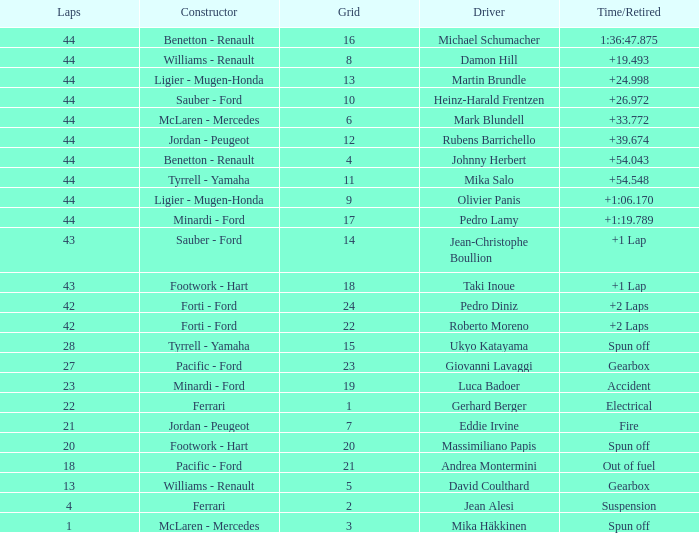Who built the car that ran out of fuel before 28 laps? Pacific - Ford. 